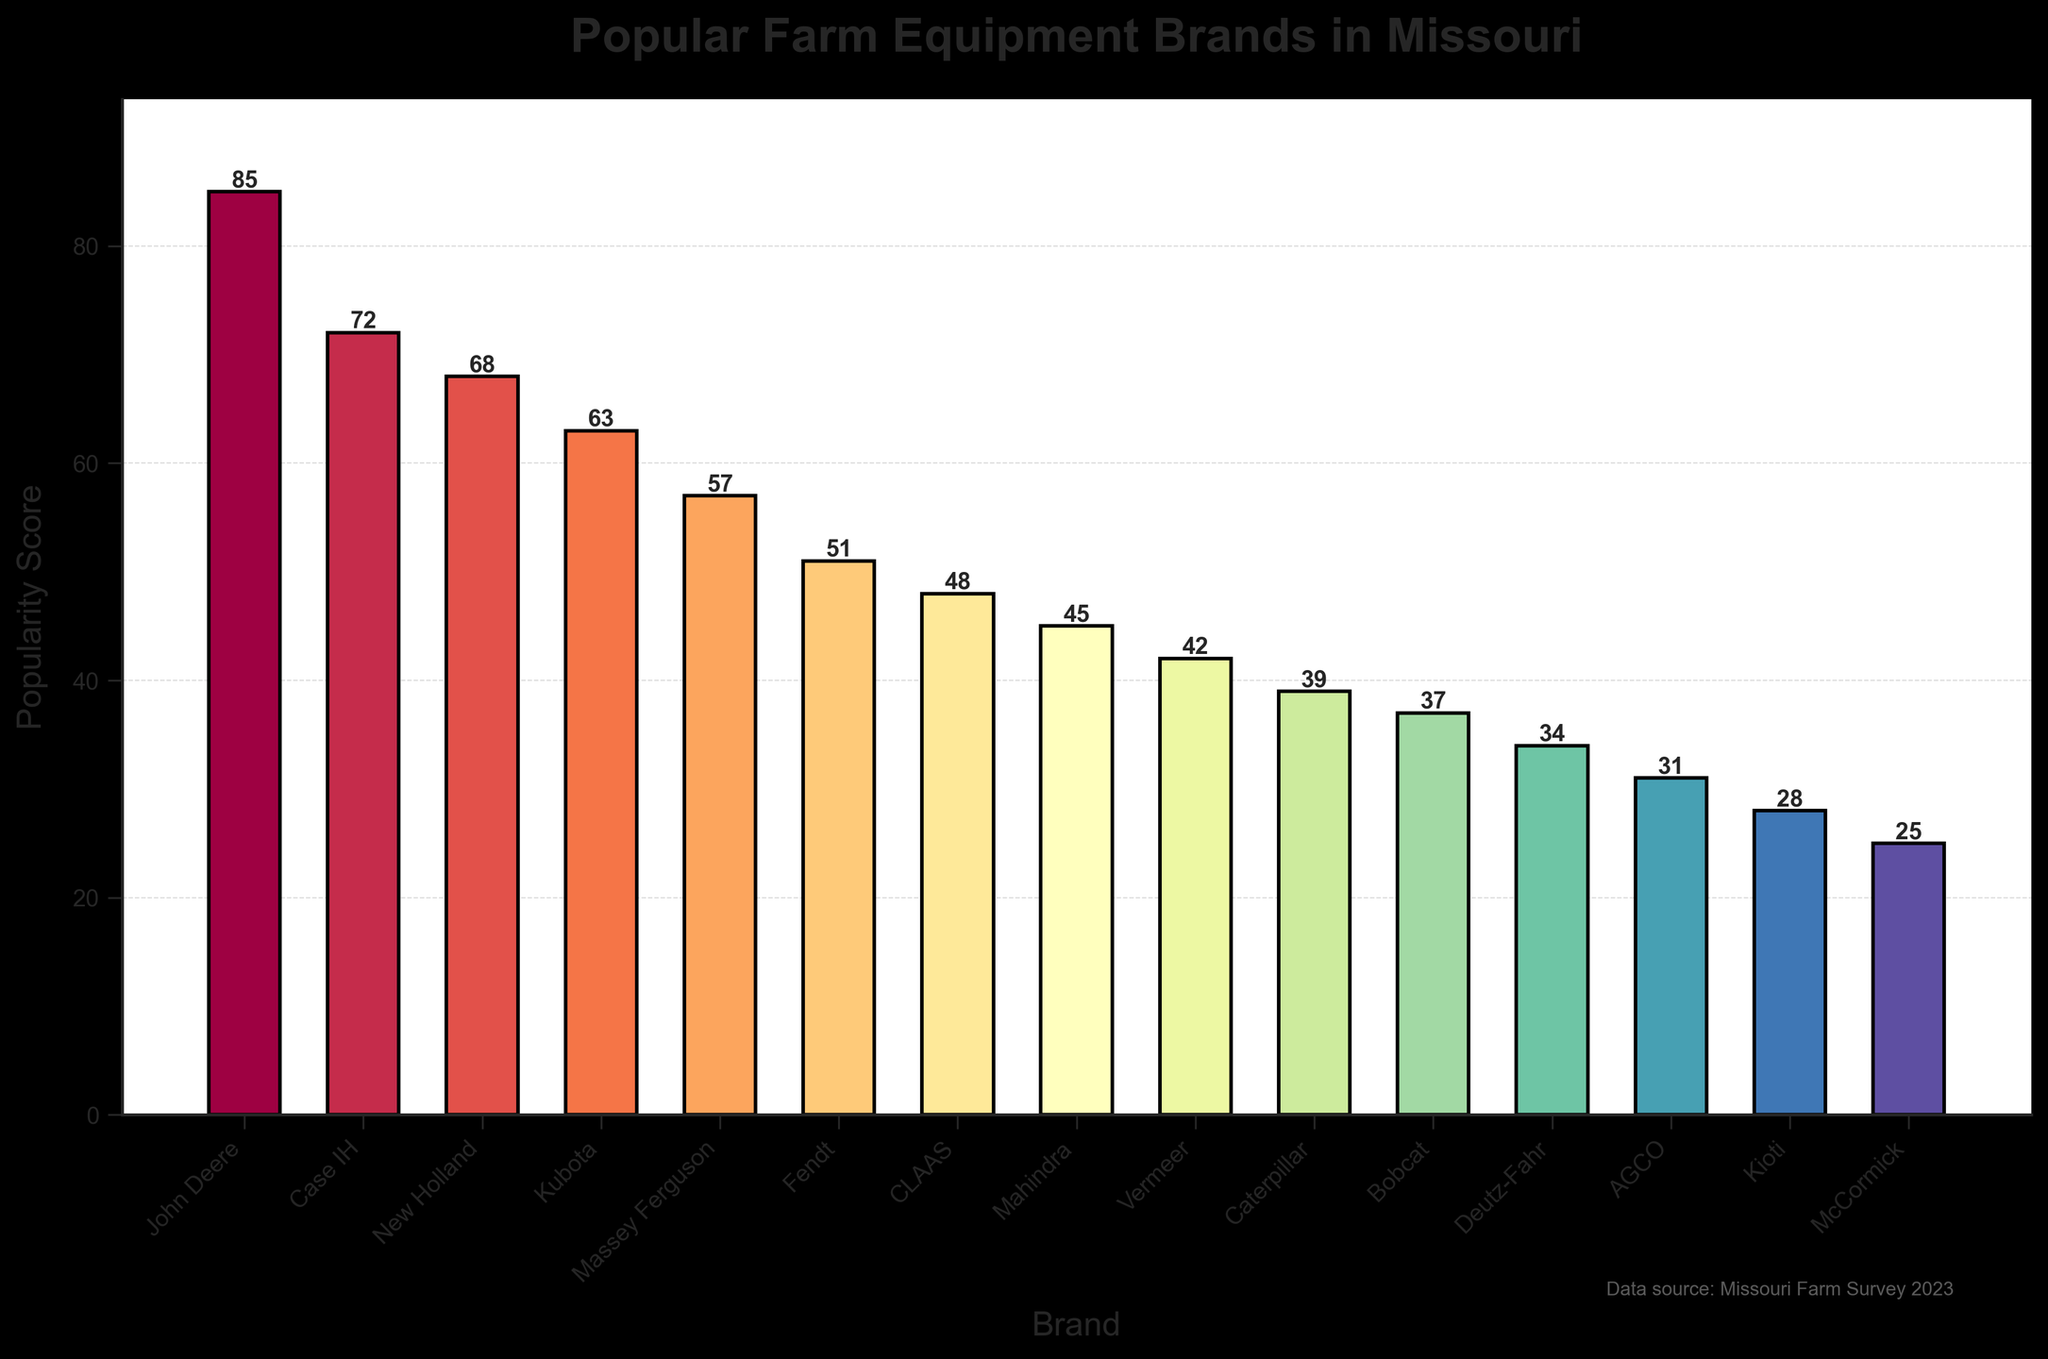Which brand has the highest popularity score? First, look for the bar that is the tallest. This corresponds to John Deere, which has the highest popularity score at 85.
Answer: John Deere What is the sum of the popularity scores of the top three brands? Find the scores of the top three brands (John Deere - 85, Case IH - 72, New Holland - 68), and then add them together: 85 + 72 + 68 = 225.
Answer: 225 Which brand is more popular, Kubota or Fendt? Compare the heights of the bars for Kubota and Fendt. Kubota's score is 63 while Fendt's score is 51, so Kubota is more popular.
Answer: Kubota How many brands have a popularity score greater than 50? Count the number of bars with heights greater than 50: John Deere, Case IH, New Holland, Kubota, Massey Ferguson, and Fendt. That's 6 brands in total.
Answer: 6 What is the difference in popularity scores between the most popular and the least popular brands? The most popular brand (John Deere) has a score of 85 and the least popular brand (McCormick) has a score of 25. Subtract 25 from 85: 85 - 25 = 60.
Answer: 60 Which brand has a popularity score closest to 50? Look at the bars whose heights are around 50. Fendt has a score of 51, which is the closest to 50.
Answer: Fendt What is the average popularity score of all brands? Sum the scores of all brands: 85 + 72 + 68 + 63 + 57 + 51 + 48 + 45 + 42 + 39 + 37 + 34 + 31 + 28 + 25 = 675. There are 15 brands, so divide the total by 15: 675 / 15 = 45.
Answer: 45 Which brand has the median popularity score? Arrange the scores in ascending order and find the middle value. The sorted scores are: 25, 28, 31, 34, 37, 39, 42, 45, 48, 51, 57, 63, 68, 72, 85. The median value, being the 8th score, is 45, which corresponds to Mahindra.
Answer: Mahindra Which two brands have the smallest difference in popularity scores? Identify the pairs of adjacent scores and calculate the differences: 85-72, 72-68, 68-63, 63-57, 57-51, 51-48, 48-45, 45-42, 42-39, 39-37, 37-34, 34-31, 31-28, 28-25. The smallest difference is 3 between CLAAS (48) and Mahindra (45).
Answer: CLAAS, Mahindra What are the colors of the bars representing John Deere and McCormick? Observe the colors of the tallest and the shortest bars. John Deere's bar is colored in a shade of dark red, while McCormick's bar is in light purple.
Answer: Dark red, light purple 